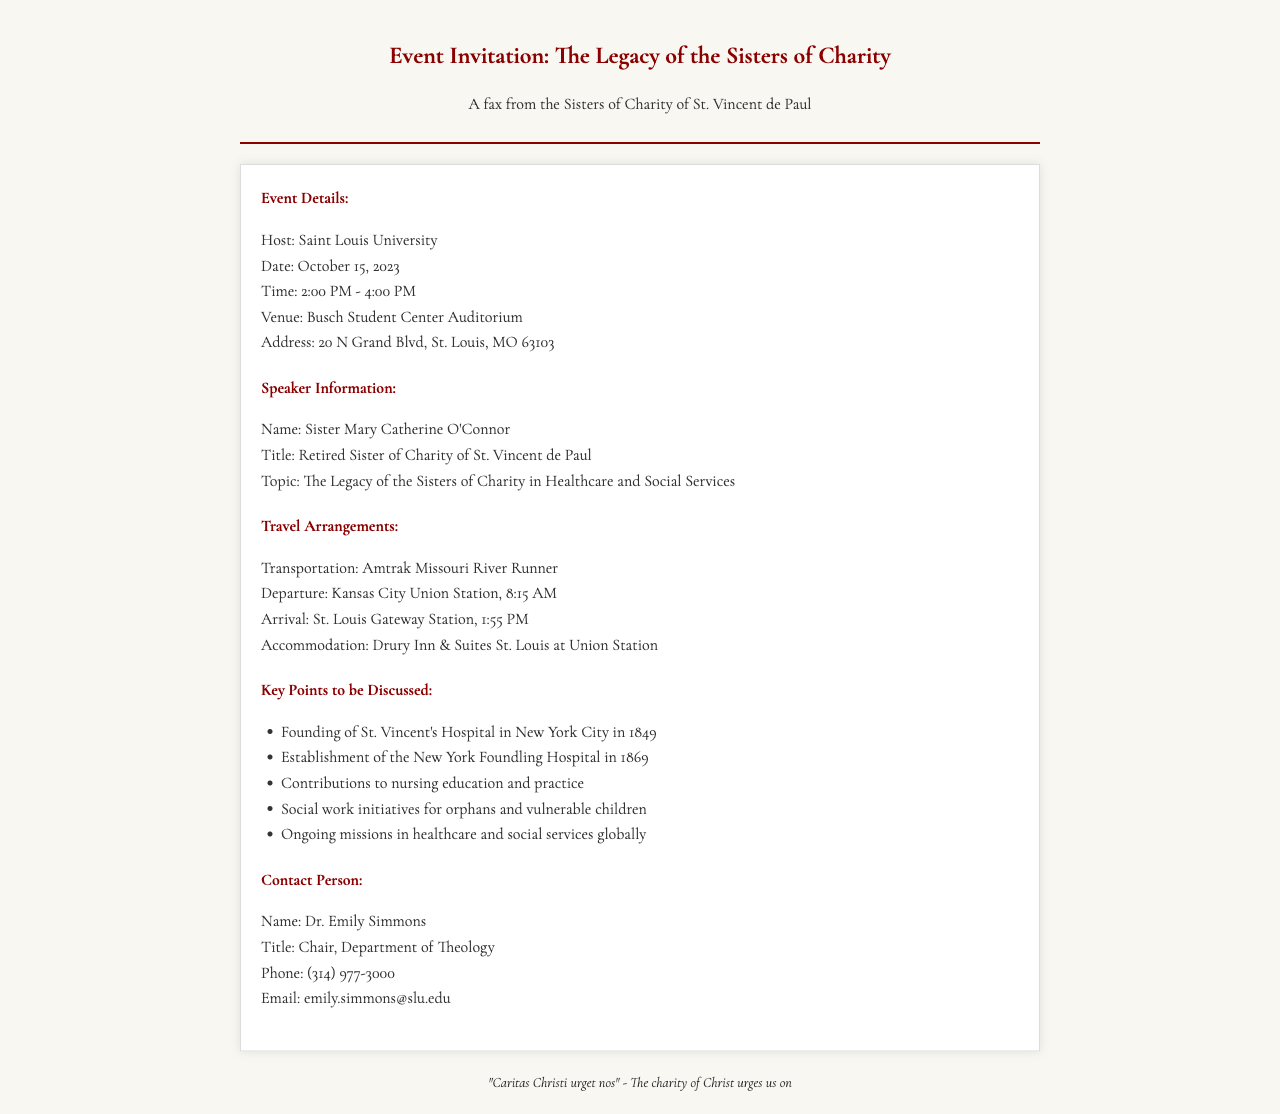What is the name of the event? The event is titled "The Legacy of the Sisters of Charity."
Answer: The Legacy of the Sisters of Charity What is the date of the event? The document specifies that the event will take place on October 15, 2023.
Answer: October 15, 2023 What transportation will be used for travel? The travel arrangements mention the "Amtrak Missouri River Runner" as the mode of transportation.
Answer: Amtrak Missouri River Runner Who is the contact person for the event? The document identifies Dr. Emily Simmons as the contact person.
Answer: Dr. Emily Simmons What time does the event start? The event is scheduled to start at 2:00 PM.
Answer: 2:00 PM What is the topic of Sister Mary Catherine O'Connor's talk? The topic outlined is "The Legacy of the Sisters of Charity in Healthcare and Social Services."
Answer: The Legacy of the Sisters of Charity in Healthcare and Social Services Which hotel will be the accommodation for the event? According to the travel arrangements, the accommodation is the "Drury Inn & Suites St. Louis at Union Station."
Answer: Drury Inn & Suites St. Louis at Union Station What is the address of the event venue? The venue address is given as 20 N Grand Blvd, St. Louis, MO 63103.
Answer: 20 N Grand Blvd, St. Louis, MO 63103 What is the ending time of the event? The document states that the event will end at 4:00 PM.
Answer: 4:00 PM 